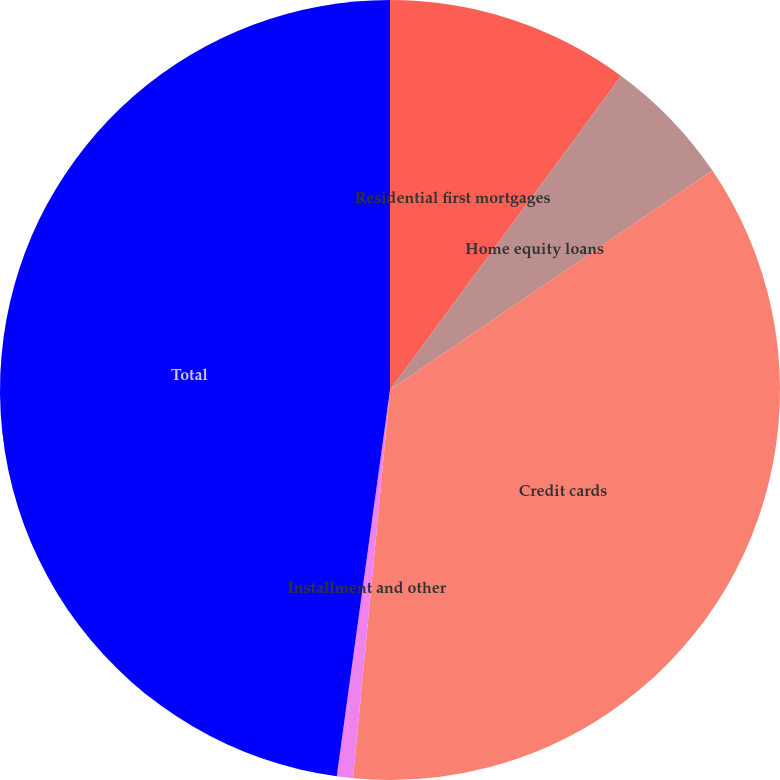<chart> <loc_0><loc_0><loc_500><loc_500><pie_chart><fcel>Residential first mortgages<fcel>Home equity loans<fcel>Credit cards<fcel>Installment and other<fcel>Total<nl><fcel>10.1%<fcel>5.39%<fcel>36.02%<fcel>0.67%<fcel>47.82%<nl></chart> 